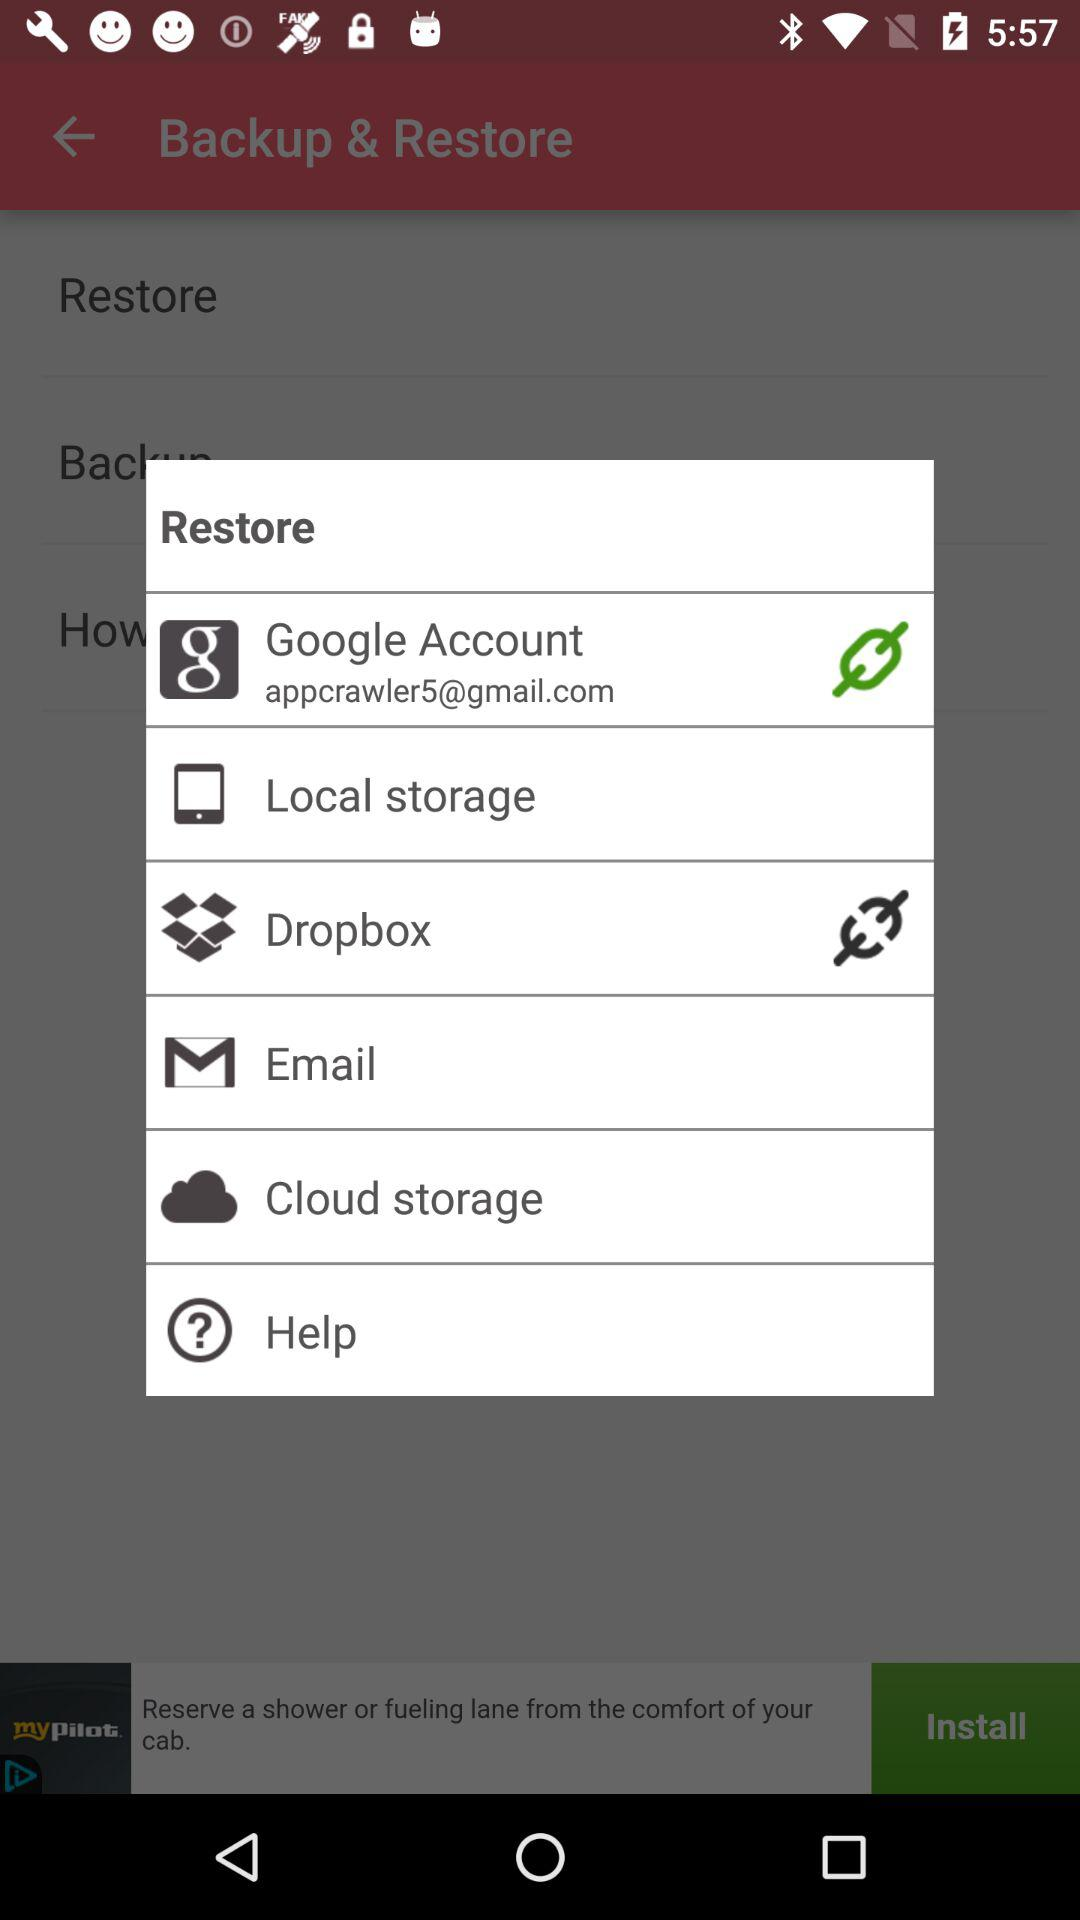What is the email address? The email address is appcrawler5@gmail.com. 